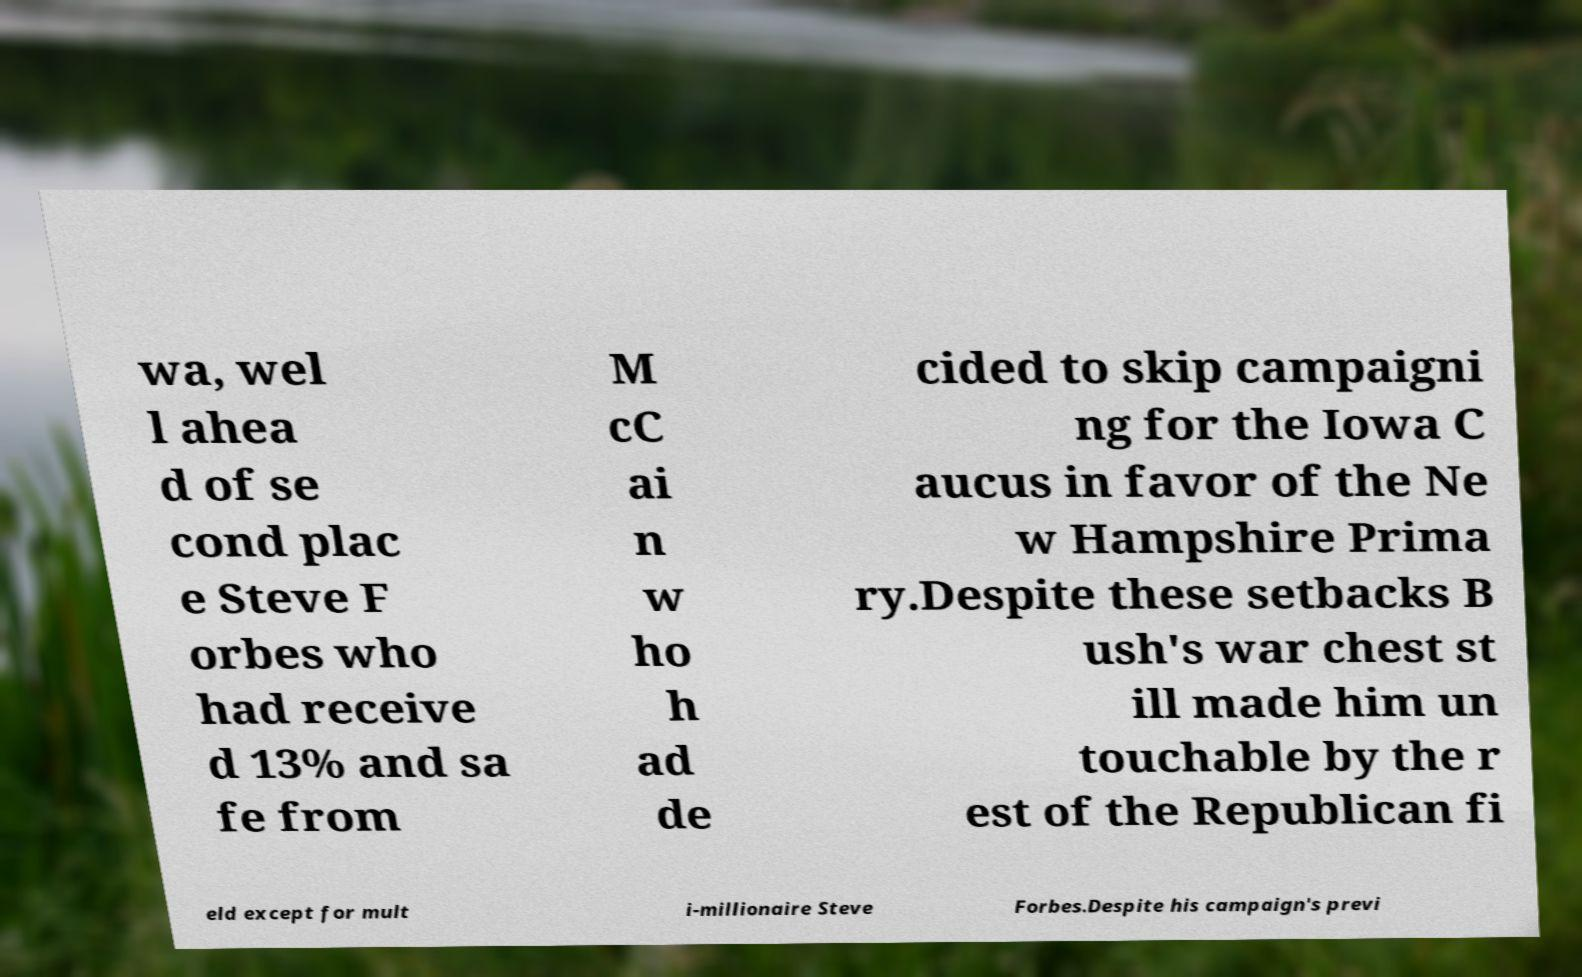There's text embedded in this image that I need extracted. Can you transcribe it verbatim? wa, wel l ahea d of se cond plac e Steve F orbes who had receive d 13% and sa fe from M cC ai n w ho h ad de cided to skip campaigni ng for the Iowa C aucus in favor of the Ne w Hampshire Prima ry.Despite these setbacks B ush's war chest st ill made him un touchable by the r est of the Republican fi eld except for mult i-millionaire Steve Forbes.Despite his campaign's previ 